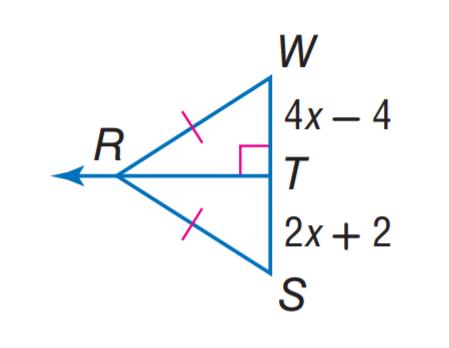Question: Find S W.
Choices:
A. 4
B. 8
C. 12
D. 16
Answer with the letter. Answer: D 